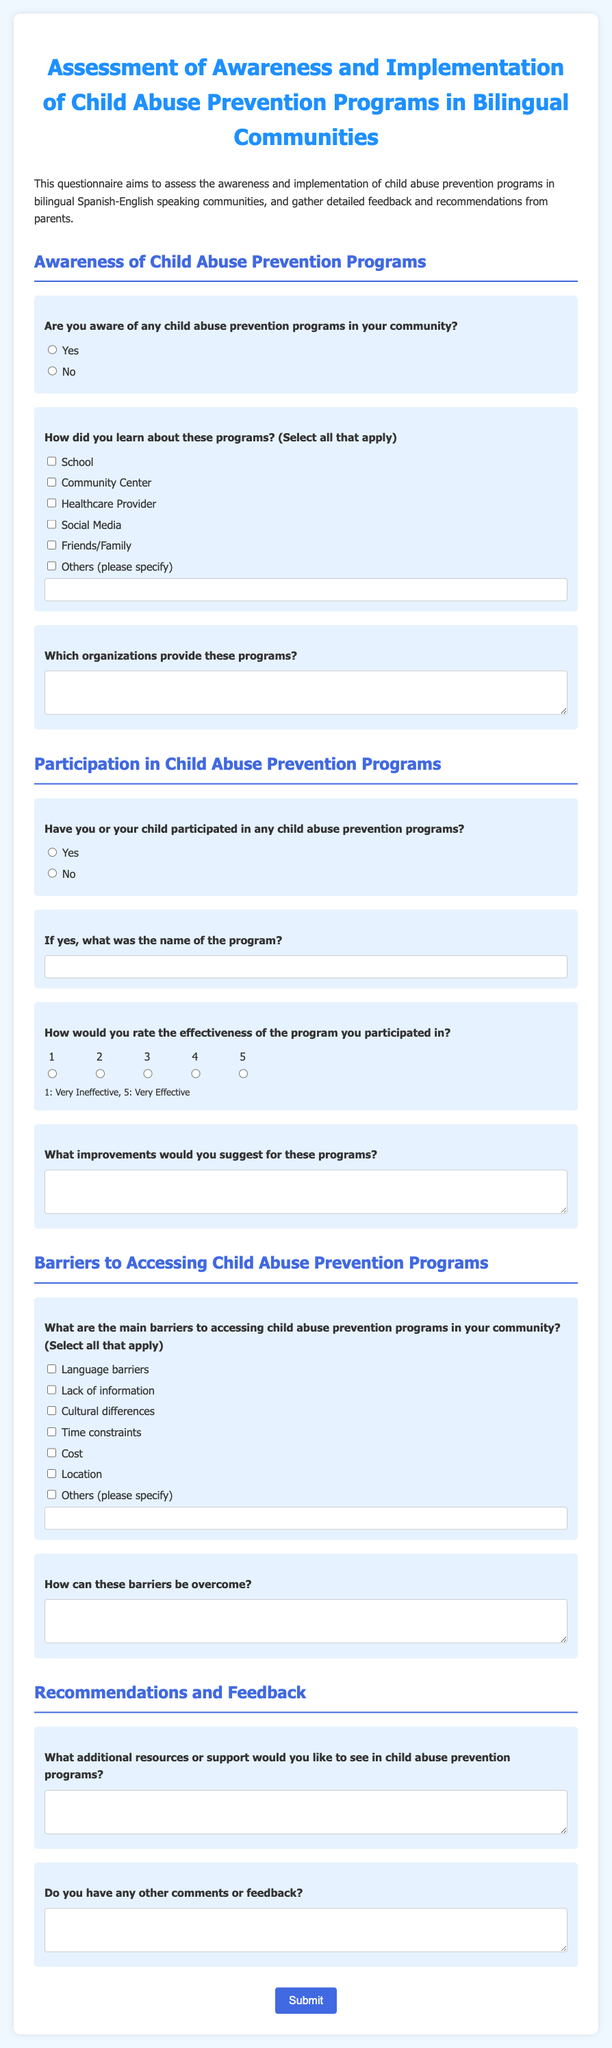Are you aware of any child abuse prevention programs in your community? This is a direct question from the document asking respondents about their awareness of programs.
Answer: Yes/No How did you learn about these programs? This question asks for the sources of information regarding the programs, allowing for multiple selections.
Answer: School, Community Center, Healthcare Provider, Social Media, Friends/Family, Others What was the name of the program? This question seeks the specific name of any child abuse prevention program the respondent or their child participated in.
Answer: [Program Name] What rating would you give the effectiveness of the program? The effectiveness rating question asks respondents to evaluate the programs they participated in on a scale from 1 to 5.
Answer: 1, 2, 3, 4, or 5 What are the main barriers to accessing child abuse prevention programs in your community? This question allows respondents to identify obstacles they face when trying to access these programs.
Answer: Language barriers, Lack of information, Cultural differences, Time constraints, Cost, Location, Others How can these barriers be overcome? This question invites respondents to suggest solutions to the barriers identified in the previous question.
Answer: [Suggestions] What additional resources would you like to see? This question seeks to gather feedback on the kinds of resources parents feel are necessary for child abuse prevention programs.
Answer: [Additional Resources] Do you have any other comments or feedback? This is an open-ended question collecting any additional thoughts or suggestions from respondents.
Answer: [Comments] 